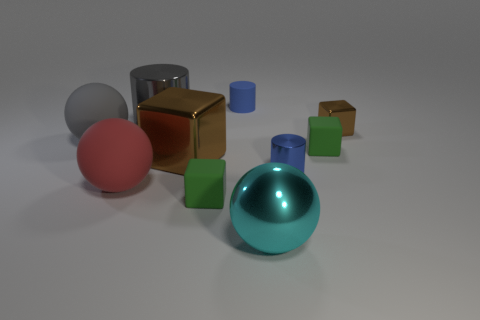Subtract all cylinders. How many objects are left? 7 Add 3 tiny green objects. How many tiny green objects are left? 5 Add 6 blue cylinders. How many blue cylinders exist? 8 Subtract 1 green cubes. How many objects are left? 9 Subtract all cylinders. Subtract all green blocks. How many objects are left? 5 